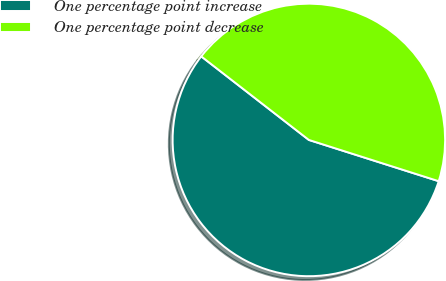<chart> <loc_0><loc_0><loc_500><loc_500><pie_chart><fcel>One percentage point increase<fcel>One percentage point decrease<nl><fcel>55.61%<fcel>44.39%<nl></chart> 